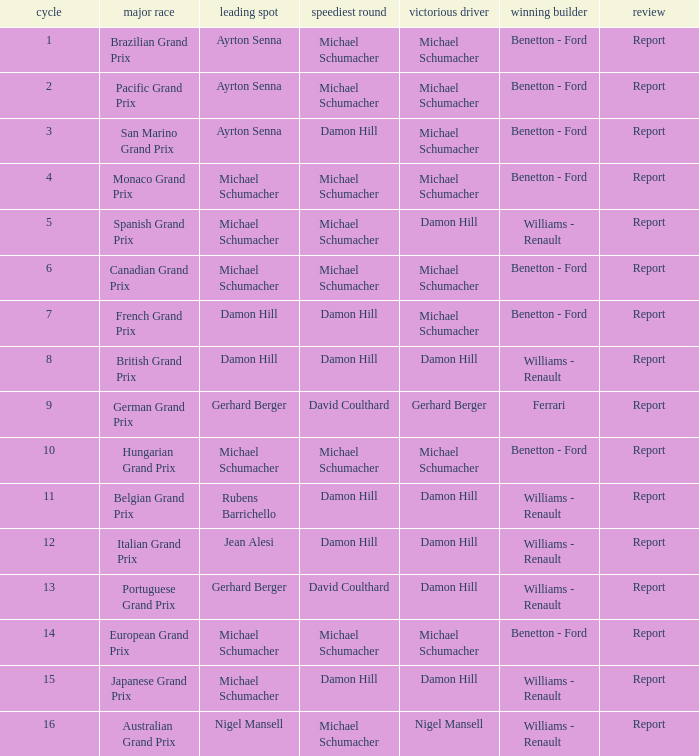Name the pole position at the japanese grand prix when the fastest lap is damon hill Michael Schumacher. 